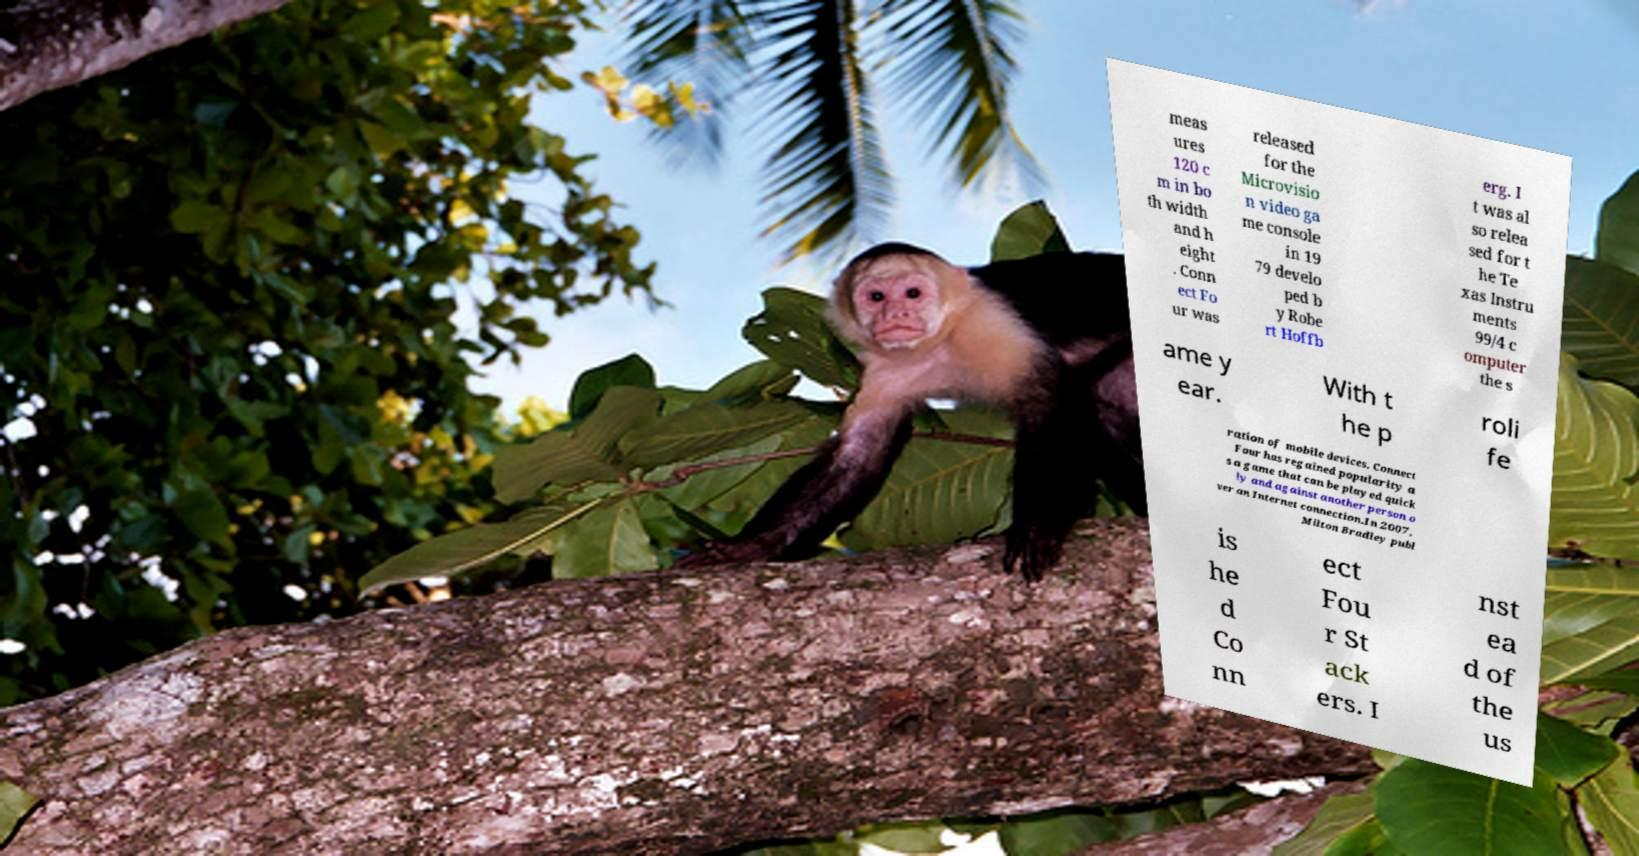Please identify and transcribe the text found in this image. meas ures 120 c m in bo th width and h eight . Conn ect Fo ur was released for the Microvisio n video ga me console in 19 79 develo ped b y Robe rt Hoffb erg. I t was al so relea sed for t he Te xas Instru ments 99/4 c omputer the s ame y ear. With t he p roli fe ration of mobile devices, Connect Four has regained popularity a s a game that can be played quick ly and against another person o ver an Internet connection.In 2007, Milton Bradley publ is he d Co nn ect Fou r St ack ers. I nst ea d of the us 